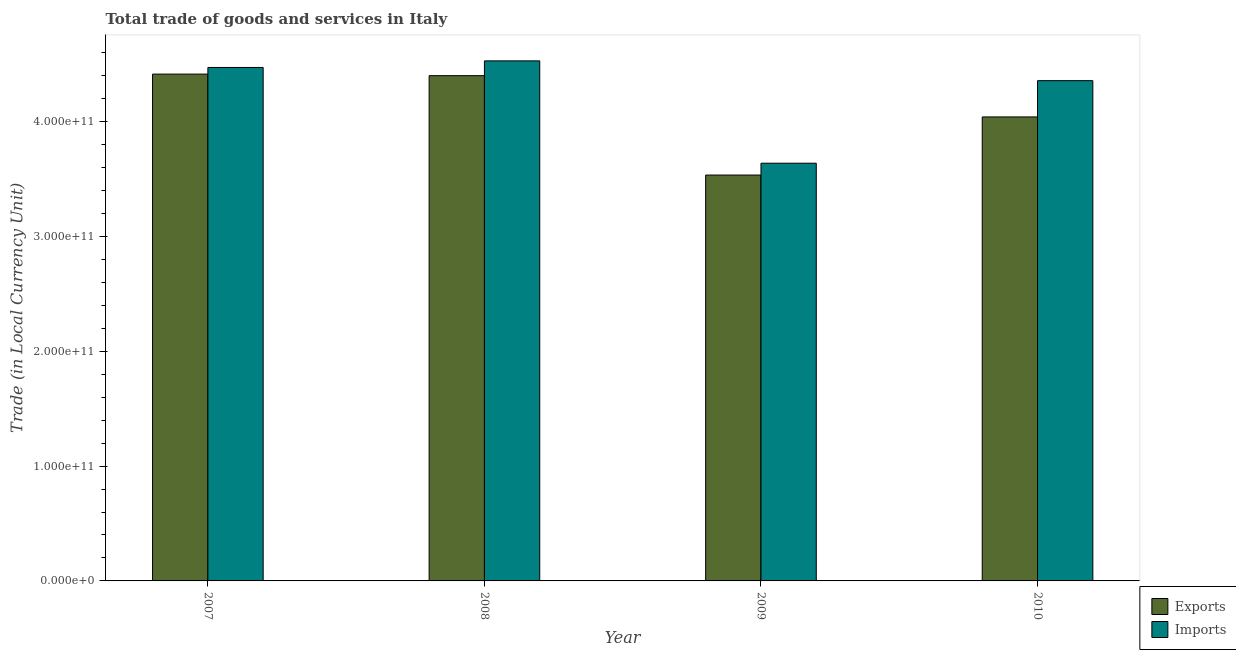How many different coloured bars are there?
Your answer should be very brief. 2. How many groups of bars are there?
Make the answer very short. 4. Are the number of bars on each tick of the X-axis equal?
Offer a terse response. Yes. How many bars are there on the 2nd tick from the left?
Make the answer very short. 2. In how many cases, is the number of bars for a given year not equal to the number of legend labels?
Ensure brevity in your answer.  0. What is the export of goods and services in 2010?
Provide a short and direct response. 4.04e+11. Across all years, what is the maximum imports of goods and services?
Ensure brevity in your answer.  4.53e+11. Across all years, what is the minimum export of goods and services?
Ensure brevity in your answer.  3.54e+11. What is the total imports of goods and services in the graph?
Your answer should be compact. 1.70e+12. What is the difference between the export of goods and services in 2007 and that in 2009?
Your answer should be compact. 8.79e+1. What is the difference between the imports of goods and services in 2009 and the export of goods and services in 2010?
Offer a very short reply. -7.19e+1. What is the average imports of goods and services per year?
Provide a succinct answer. 4.25e+11. In the year 2007, what is the difference between the imports of goods and services and export of goods and services?
Make the answer very short. 0. In how many years, is the imports of goods and services greater than 220000000000 LCU?
Offer a very short reply. 4. What is the ratio of the imports of goods and services in 2007 to that in 2009?
Offer a terse response. 1.23. Is the imports of goods and services in 2008 less than that in 2010?
Offer a terse response. No. Is the difference between the export of goods and services in 2008 and 2010 greater than the difference between the imports of goods and services in 2008 and 2010?
Give a very brief answer. No. What is the difference between the highest and the second highest export of goods and services?
Give a very brief answer. 1.35e+09. What is the difference between the highest and the lowest export of goods and services?
Give a very brief answer. 8.79e+1. In how many years, is the export of goods and services greater than the average export of goods and services taken over all years?
Make the answer very short. 2. Is the sum of the imports of goods and services in 2007 and 2009 greater than the maximum export of goods and services across all years?
Provide a succinct answer. Yes. What does the 2nd bar from the left in 2009 represents?
Offer a terse response. Imports. What does the 2nd bar from the right in 2010 represents?
Give a very brief answer. Exports. What is the difference between two consecutive major ticks on the Y-axis?
Provide a short and direct response. 1.00e+11. Are the values on the major ticks of Y-axis written in scientific E-notation?
Give a very brief answer. Yes. How many legend labels are there?
Offer a very short reply. 2. What is the title of the graph?
Your answer should be very brief. Total trade of goods and services in Italy. Does "Agricultural land" appear as one of the legend labels in the graph?
Ensure brevity in your answer.  No. What is the label or title of the X-axis?
Provide a succinct answer. Year. What is the label or title of the Y-axis?
Provide a short and direct response. Trade (in Local Currency Unit). What is the Trade (in Local Currency Unit) in Exports in 2007?
Keep it short and to the point. 4.41e+11. What is the Trade (in Local Currency Unit) in Imports in 2007?
Offer a very short reply. 4.47e+11. What is the Trade (in Local Currency Unit) of Exports in 2008?
Offer a terse response. 4.40e+11. What is the Trade (in Local Currency Unit) in Imports in 2008?
Ensure brevity in your answer.  4.53e+11. What is the Trade (in Local Currency Unit) of Exports in 2009?
Your response must be concise. 3.54e+11. What is the Trade (in Local Currency Unit) of Imports in 2009?
Your answer should be compact. 3.64e+11. What is the Trade (in Local Currency Unit) in Exports in 2010?
Your answer should be very brief. 4.04e+11. What is the Trade (in Local Currency Unit) of Imports in 2010?
Provide a succinct answer. 4.36e+11. Across all years, what is the maximum Trade (in Local Currency Unit) in Exports?
Ensure brevity in your answer.  4.41e+11. Across all years, what is the maximum Trade (in Local Currency Unit) of Imports?
Ensure brevity in your answer.  4.53e+11. Across all years, what is the minimum Trade (in Local Currency Unit) in Exports?
Your answer should be very brief. 3.54e+11. Across all years, what is the minimum Trade (in Local Currency Unit) in Imports?
Keep it short and to the point. 3.64e+11. What is the total Trade (in Local Currency Unit) of Exports in the graph?
Ensure brevity in your answer.  1.64e+12. What is the total Trade (in Local Currency Unit) of Imports in the graph?
Provide a short and direct response. 1.70e+12. What is the difference between the Trade (in Local Currency Unit) in Exports in 2007 and that in 2008?
Keep it short and to the point. 1.35e+09. What is the difference between the Trade (in Local Currency Unit) of Imports in 2007 and that in 2008?
Make the answer very short. -5.74e+09. What is the difference between the Trade (in Local Currency Unit) of Exports in 2007 and that in 2009?
Your answer should be compact. 8.79e+1. What is the difference between the Trade (in Local Currency Unit) in Imports in 2007 and that in 2009?
Keep it short and to the point. 8.34e+1. What is the difference between the Trade (in Local Currency Unit) of Exports in 2007 and that in 2010?
Provide a succinct answer. 3.73e+1. What is the difference between the Trade (in Local Currency Unit) of Imports in 2007 and that in 2010?
Ensure brevity in your answer.  1.15e+1. What is the difference between the Trade (in Local Currency Unit) of Exports in 2008 and that in 2009?
Offer a terse response. 8.66e+1. What is the difference between the Trade (in Local Currency Unit) in Imports in 2008 and that in 2009?
Provide a succinct answer. 8.91e+1. What is the difference between the Trade (in Local Currency Unit) in Exports in 2008 and that in 2010?
Keep it short and to the point. 3.60e+1. What is the difference between the Trade (in Local Currency Unit) in Imports in 2008 and that in 2010?
Your response must be concise. 1.72e+1. What is the difference between the Trade (in Local Currency Unit) in Exports in 2009 and that in 2010?
Your answer should be very brief. -5.06e+1. What is the difference between the Trade (in Local Currency Unit) of Imports in 2009 and that in 2010?
Your answer should be compact. -7.19e+1. What is the difference between the Trade (in Local Currency Unit) in Exports in 2007 and the Trade (in Local Currency Unit) in Imports in 2008?
Provide a succinct answer. -1.15e+1. What is the difference between the Trade (in Local Currency Unit) of Exports in 2007 and the Trade (in Local Currency Unit) of Imports in 2009?
Provide a short and direct response. 7.76e+1. What is the difference between the Trade (in Local Currency Unit) in Exports in 2007 and the Trade (in Local Currency Unit) in Imports in 2010?
Offer a terse response. 5.71e+09. What is the difference between the Trade (in Local Currency Unit) of Exports in 2008 and the Trade (in Local Currency Unit) of Imports in 2009?
Your answer should be compact. 7.63e+1. What is the difference between the Trade (in Local Currency Unit) of Exports in 2008 and the Trade (in Local Currency Unit) of Imports in 2010?
Your response must be concise. 4.36e+09. What is the difference between the Trade (in Local Currency Unit) of Exports in 2009 and the Trade (in Local Currency Unit) of Imports in 2010?
Offer a terse response. -8.22e+1. What is the average Trade (in Local Currency Unit) in Exports per year?
Provide a succinct answer. 4.10e+11. What is the average Trade (in Local Currency Unit) of Imports per year?
Make the answer very short. 4.25e+11. In the year 2007, what is the difference between the Trade (in Local Currency Unit) of Exports and Trade (in Local Currency Unit) of Imports?
Ensure brevity in your answer.  -5.78e+09. In the year 2008, what is the difference between the Trade (in Local Currency Unit) in Exports and Trade (in Local Currency Unit) in Imports?
Give a very brief answer. -1.29e+1. In the year 2009, what is the difference between the Trade (in Local Currency Unit) in Exports and Trade (in Local Currency Unit) in Imports?
Offer a terse response. -1.03e+1. In the year 2010, what is the difference between the Trade (in Local Currency Unit) of Exports and Trade (in Local Currency Unit) of Imports?
Offer a terse response. -3.16e+1. What is the ratio of the Trade (in Local Currency Unit) in Exports in 2007 to that in 2008?
Your answer should be very brief. 1. What is the ratio of the Trade (in Local Currency Unit) in Imports in 2007 to that in 2008?
Keep it short and to the point. 0.99. What is the ratio of the Trade (in Local Currency Unit) of Exports in 2007 to that in 2009?
Your answer should be compact. 1.25. What is the ratio of the Trade (in Local Currency Unit) of Imports in 2007 to that in 2009?
Your response must be concise. 1.23. What is the ratio of the Trade (in Local Currency Unit) in Exports in 2007 to that in 2010?
Keep it short and to the point. 1.09. What is the ratio of the Trade (in Local Currency Unit) of Imports in 2007 to that in 2010?
Offer a very short reply. 1.03. What is the ratio of the Trade (in Local Currency Unit) of Exports in 2008 to that in 2009?
Provide a succinct answer. 1.24. What is the ratio of the Trade (in Local Currency Unit) of Imports in 2008 to that in 2009?
Your answer should be compact. 1.25. What is the ratio of the Trade (in Local Currency Unit) of Exports in 2008 to that in 2010?
Offer a very short reply. 1.09. What is the ratio of the Trade (in Local Currency Unit) of Imports in 2008 to that in 2010?
Make the answer very short. 1.04. What is the ratio of the Trade (in Local Currency Unit) of Exports in 2009 to that in 2010?
Keep it short and to the point. 0.87. What is the ratio of the Trade (in Local Currency Unit) of Imports in 2009 to that in 2010?
Offer a very short reply. 0.83. What is the difference between the highest and the second highest Trade (in Local Currency Unit) in Exports?
Keep it short and to the point. 1.35e+09. What is the difference between the highest and the second highest Trade (in Local Currency Unit) of Imports?
Keep it short and to the point. 5.74e+09. What is the difference between the highest and the lowest Trade (in Local Currency Unit) of Exports?
Provide a short and direct response. 8.79e+1. What is the difference between the highest and the lowest Trade (in Local Currency Unit) in Imports?
Make the answer very short. 8.91e+1. 